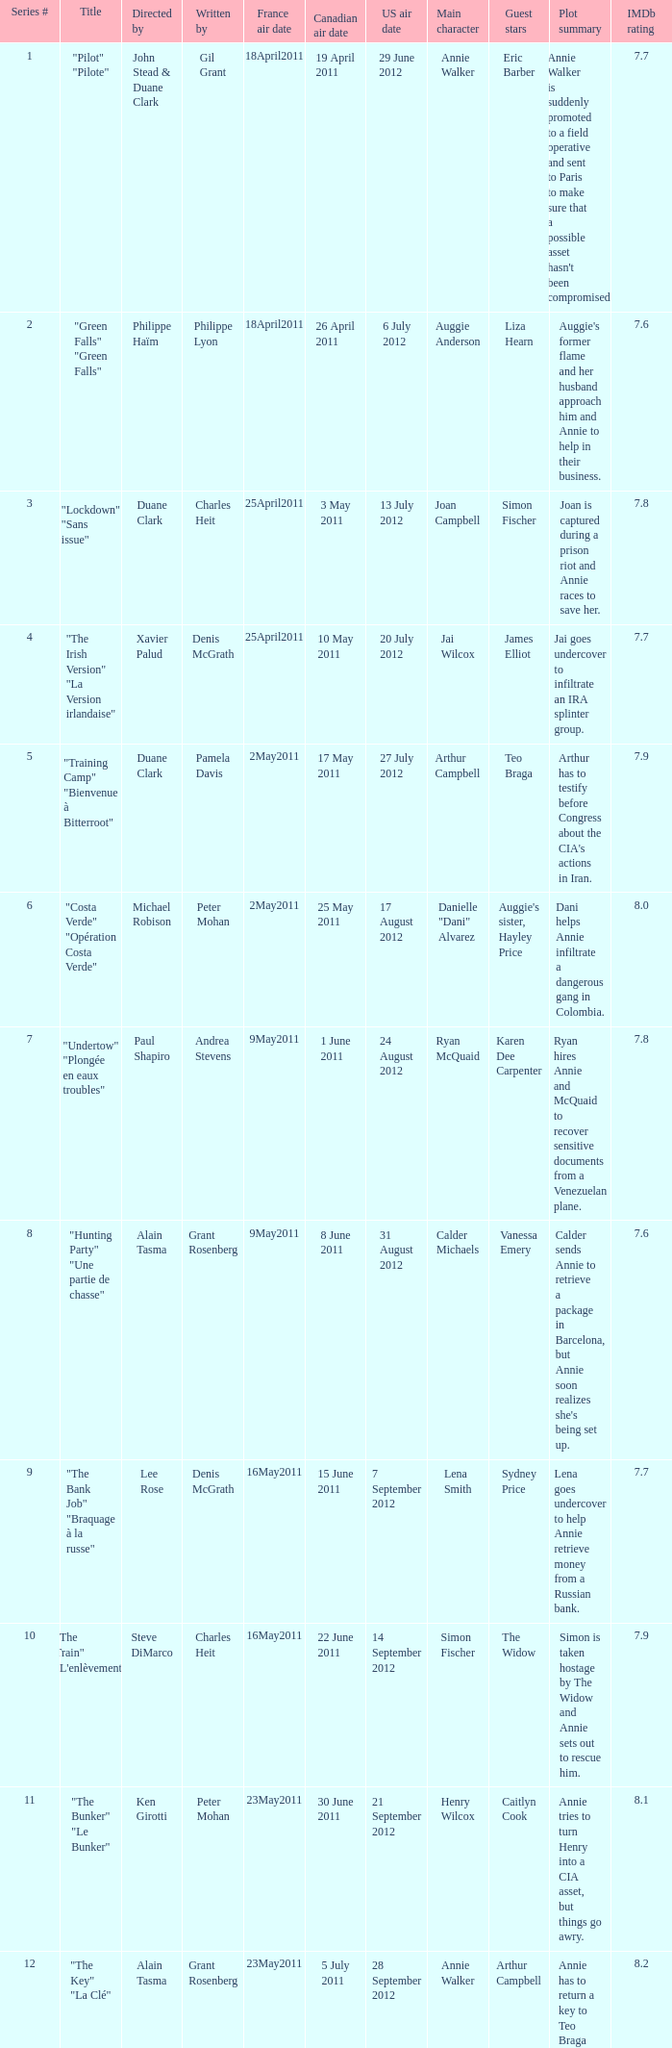What is the series # when the US air date is 20 July 2012? 4.0. 